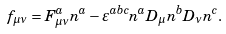Convert formula to latex. <formula><loc_0><loc_0><loc_500><loc_500>f _ { \mu \nu } = F _ { \mu \nu } ^ { a } n ^ { a } - \varepsilon ^ { a b c } n ^ { a } D _ { \mu } n ^ { b } D _ { \nu } n ^ { c } .</formula> 